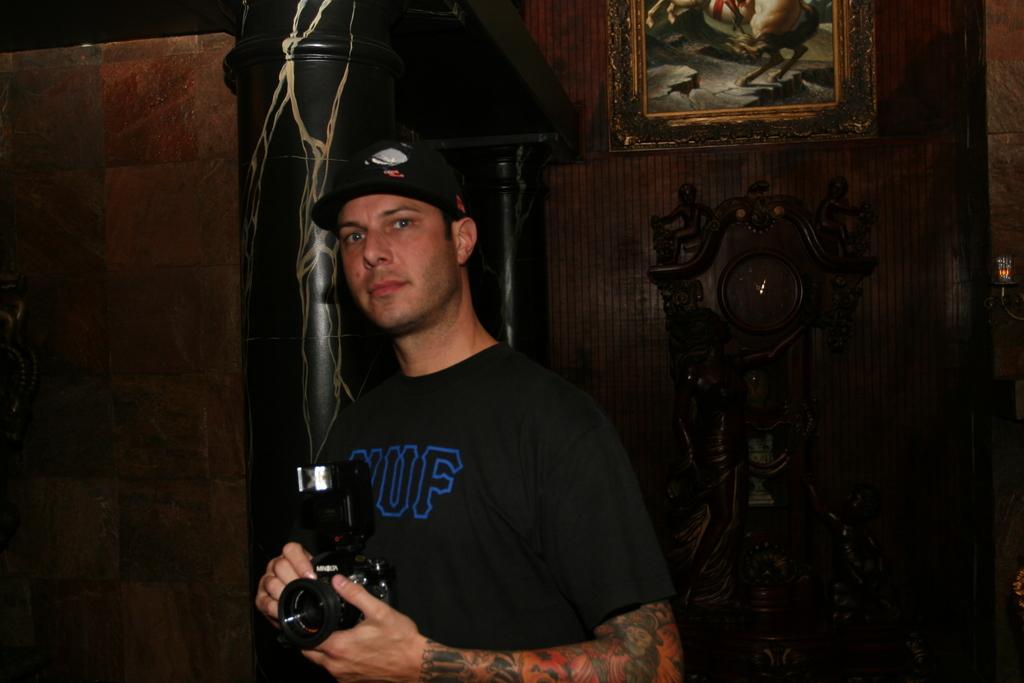How would you summarize this image in a sentence or two? in the picture there is a person catching a camera here there is a wall ,on the wall there is a frame. 